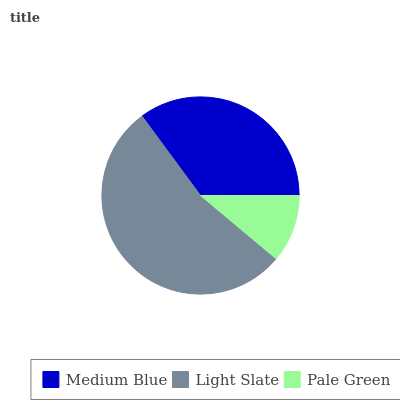Is Pale Green the minimum?
Answer yes or no. Yes. Is Light Slate the maximum?
Answer yes or no. Yes. Is Light Slate the minimum?
Answer yes or no. No. Is Pale Green the maximum?
Answer yes or no. No. Is Light Slate greater than Pale Green?
Answer yes or no. Yes. Is Pale Green less than Light Slate?
Answer yes or no. Yes. Is Pale Green greater than Light Slate?
Answer yes or no. No. Is Light Slate less than Pale Green?
Answer yes or no. No. Is Medium Blue the high median?
Answer yes or no. Yes. Is Medium Blue the low median?
Answer yes or no. Yes. Is Light Slate the high median?
Answer yes or no. No. Is Light Slate the low median?
Answer yes or no. No. 